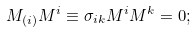Convert formula to latex. <formula><loc_0><loc_0><loc_500><loc_500>M _ { ( i ) } M ^ { i } \equiv \sigma _ { i k } M ^ { i } M ^ { k } = 0 ;</formula> 